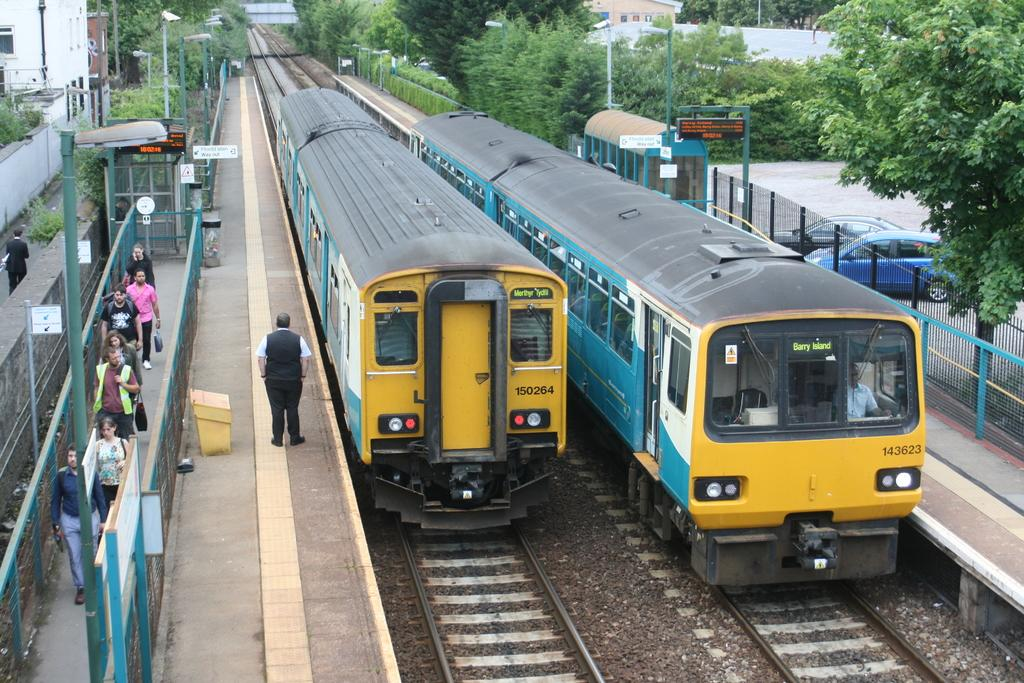What type of vehicles can be seen in the image? There are two trains in the image. What else is happening in the image besides the trains? There are people walking on a platform in the image. Are there any other modes of transportation visible in the image? Yes, there are two cars visible in the image. What can be seen in the background of the image? There are trees in the background of the image. How many rings are being exchanged between the people on the platform in the image? There are no rings being exchanged in the image; it features two trains and people walking on a platform. Can you describe the stretching abilities of the trees in the background? The trees in the background do not have any stretching abilities; they are stationary and not depicted as moving or stretching in any way. 